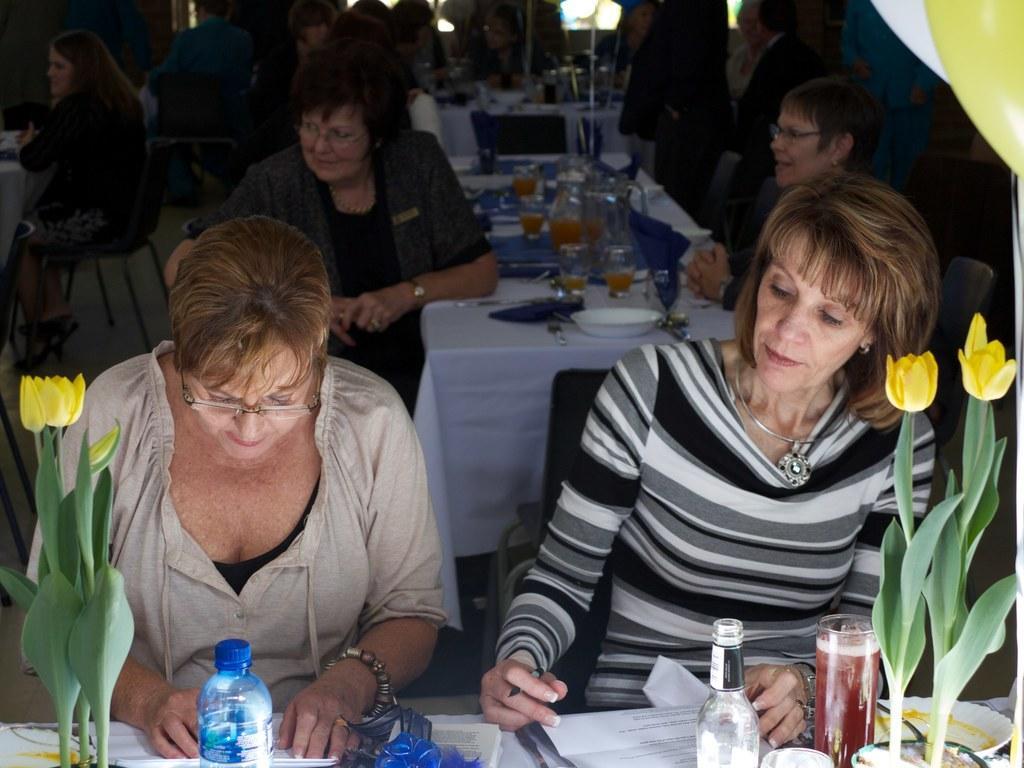How would you summarize this image in a sentence or two? In this image there are group of people sitting on the chair. On the table there is a water bottle,flower pot,paper,plate,spoon. glass. 